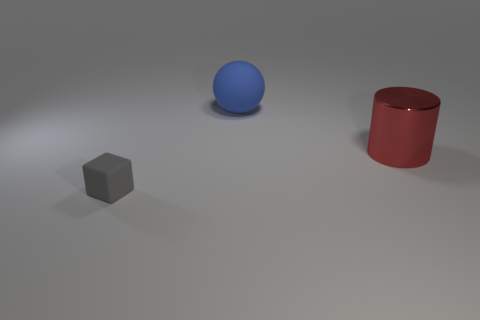Is there any other thing that has the same material as the large cylinder?
Ensure brevity in your answer.  No. Is the material of the big red cylinder the same as the large thing that is behind the metal object?
Give a very brief answer. No. The object that is to the left of the large object that is left of the metallic cylinder is made of what material?
Ensure brevity in your answer.  Rubber. Is the number of big objects that are on the right side of the blue object greater than the number of blue things?
Provide a succinct answer. No. Are there any big balls?
Offer a very short reply. Yes. There is a large thing that is behind the metal cylinder; what color is it?
Keep it short and to the point. Blue. There is a blue ball that is the same size as the red cylinder; what is it made of?
Ensure brevity in your answer.  Rubber. What number of other objects are the same material as the large ball?
Your answer should be compact. 1. The object that is left of the metal object and behind the small rubber object is what color?
Ensure brevity in your answer.  Blue. What number of things are objects behind the gray rubber object or gray matte blocks?
Provide a short and direct response. 3. 